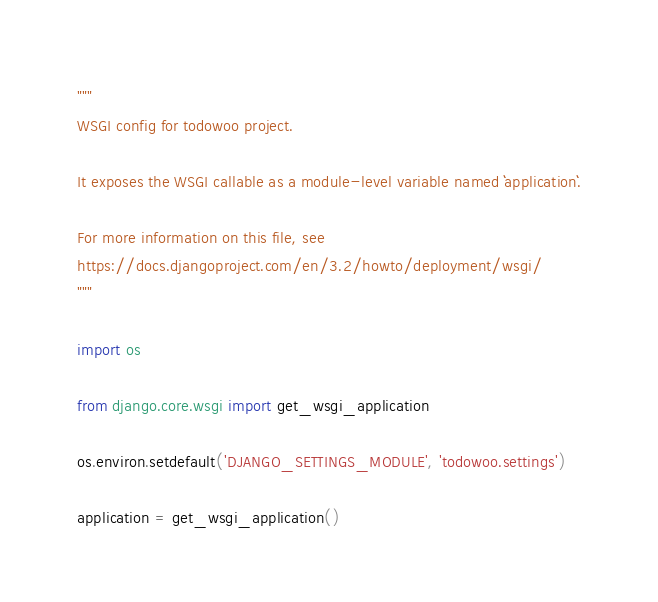<code> <loc_0><loc_0><loc_500><loc_500><_Python_>"""
WSGI config for todowoo project.

It exposes the WSGI callable as a module-level variable named ``application``.

For more information on this file, see
https://docs.djangoproject.com/en/3.2/howto/deployment/wsgi/
"""

import os

from django.core.wsgi import get_wsgi_application

os.environ.setdefault('DJANGO_SETTINGS_MODULE', 'todowoo.settings')

application = get_wsgi_application()
</code> 